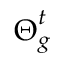Convert formula to latex. <formula><loc_0><loc_0><loc_500><loc_500>\Theta _ { g } ^ { t }</formula> 